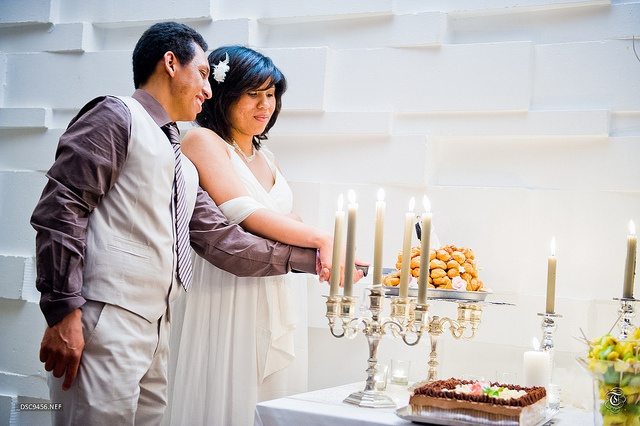Describe the objects in this image and their specific colors. I can see people in gray, lightgray, black, and darkgray tones, people in gray, lightgray, darkgray, tan, and black tones, cake in gray, brown, lightgray, and maroon tones, dining table in gray, white, darkgray, and lightgray tones, and tie in gray, lightgray, darkgray, and lavender tones in this image. 